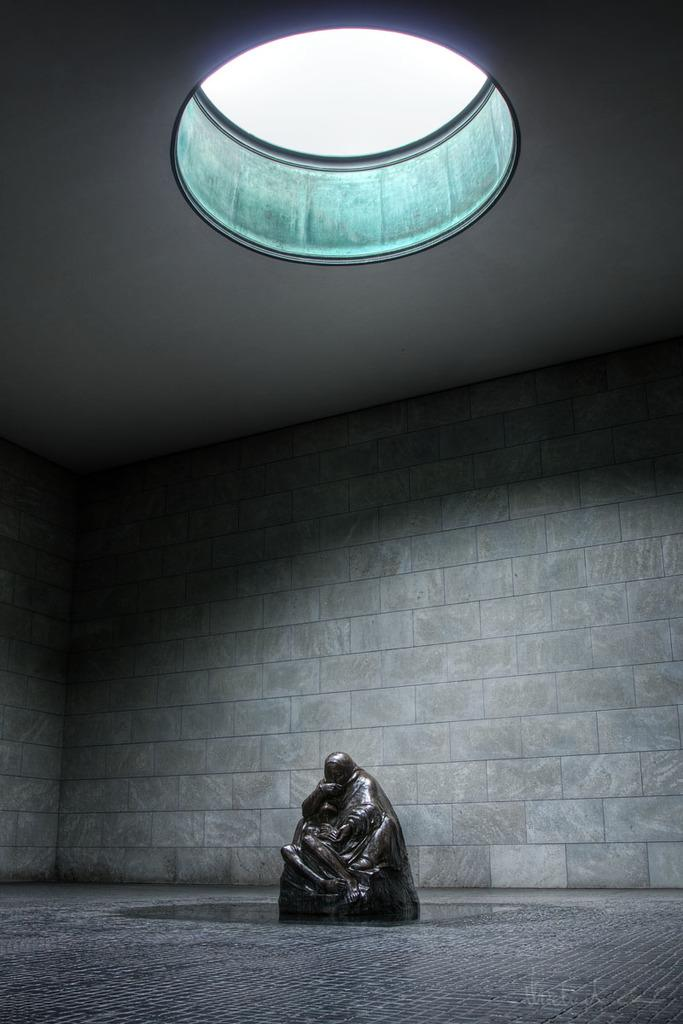What is the main subject in the image? There is a statue in the image. What can be seen in the background of the image? There is a wall in the background of the image. How many points does the statue have in the image? The statue does not have points; it is a solid object. 